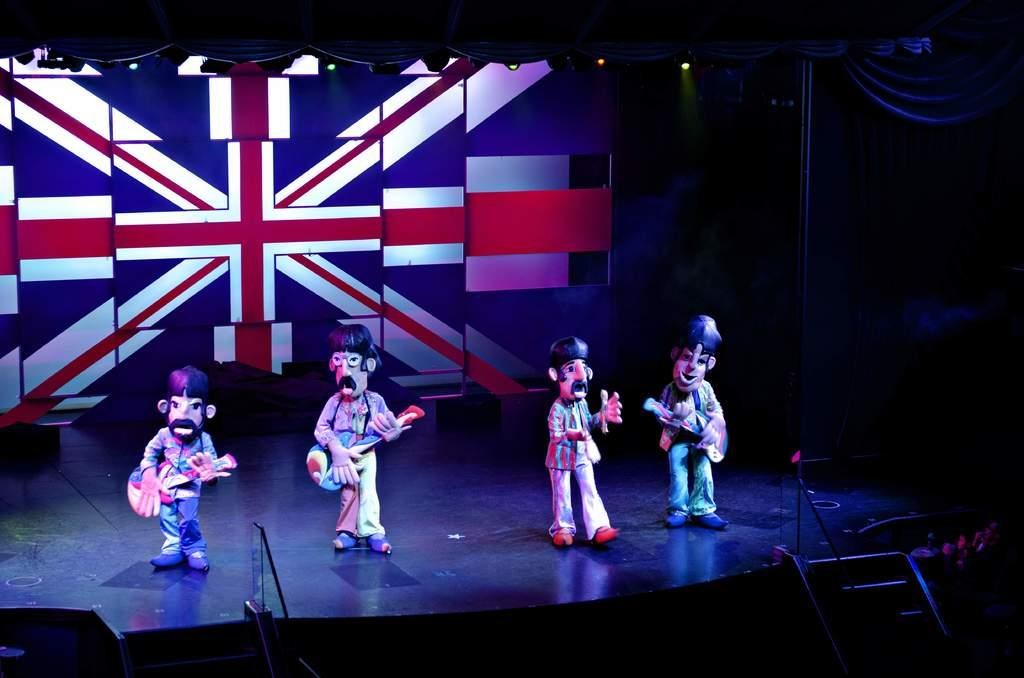How many mascots are on the stage in the image? There are four mascots on the stage in the image. What can be seen in the image that might be used for accessing the stage? There are stairs in the image. What type of lighting is present in the image? Focus lights are present in the image. What type of fabric is visible in the image? There are curtains in the image. What is in the background of the image? There is a screen in the background of the image. What type of yarn is being used by the mascots in the image? There is no yarn present in the image; the mascots are not using any yarn. 